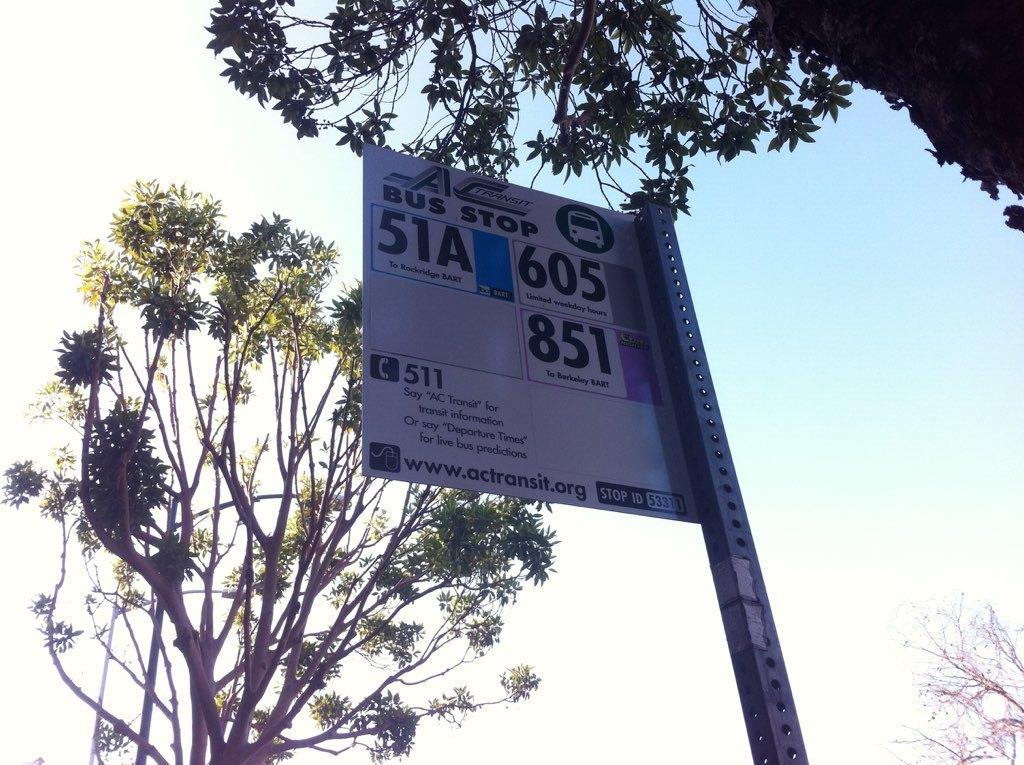What is the main object in the image? There is a hoarding board in the image. What else can be seen in the image besides the hoarding board? There are trees in the image. What part of the natural environment is visible in the image? The sky is visible in the image. How many sheep are visible on the edge of the hoarding board in the image? There are no sheep present in the image, and the edge of the hoarding board is not visible. 